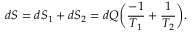Convert formula to latex. <formula><loc_0><loc_0><loc_500><loc_500>d S = d S _ { 1 } + d S _ { 2 } = d Q \left ( { \frac { - 1 } { T _ { 1 } } } + { \frac { 1 } { T _ { 2 } } } \right ) .</formula> 